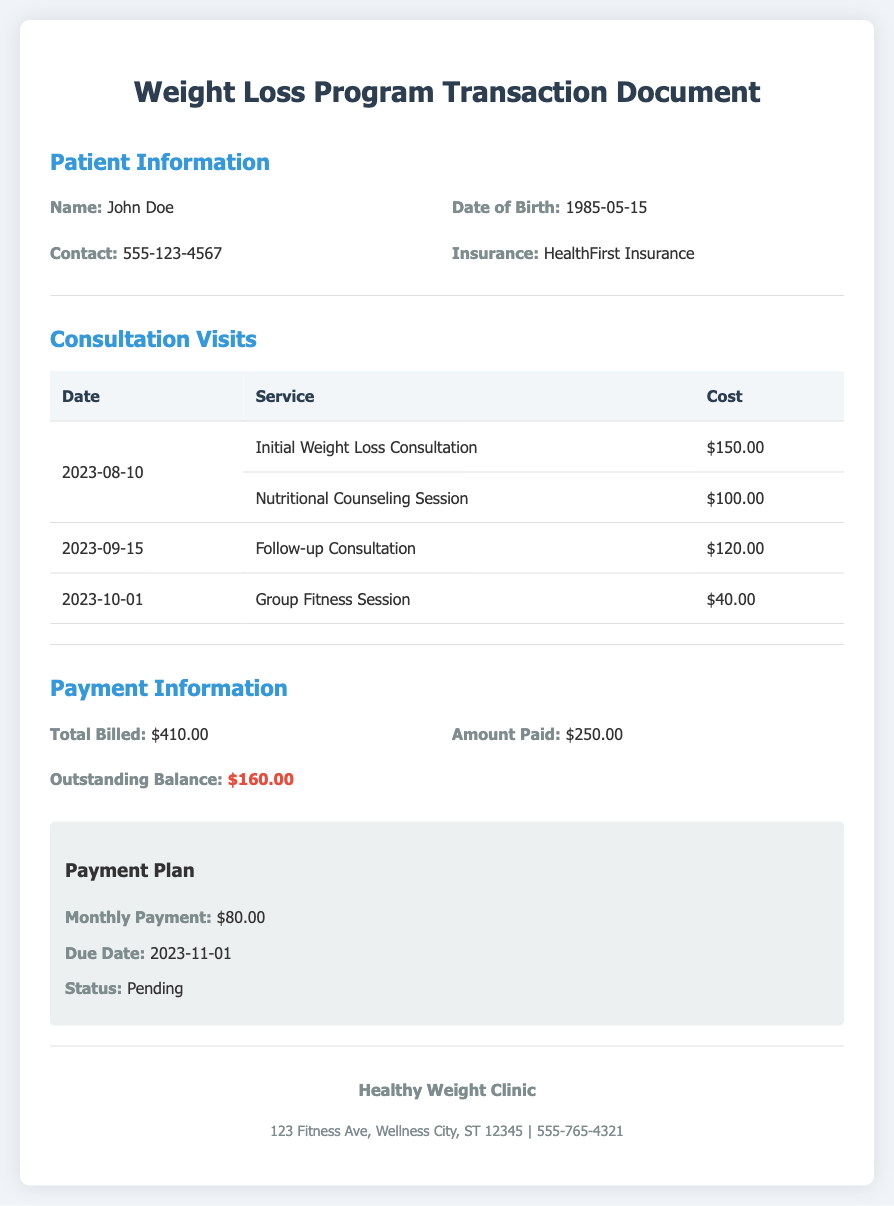What is the patient's name? The document specifies the patient's name in the patient information section.
Answer: John Doe What is the total billed amount? The total billed amount can be found in the payment information section of the document.
Answer: $410.00 What date is the outstanding balance due? The due date is highlighted in the payment plan within the payment information section.
Answer: 2023-11-01 How much was paid so far? The amount paid is listed directly in the payment information section.
Answer: $250.00 Which service was rendered on 2023-09-15? The specific service provided on this date is recorded under consultation visits.
Answer: Follow-up Consultation What is the outstanding balance? The outstanding balance is explicitly indicated in the payment information section as the difference between total billed and amount paid.
Answer: $160.00 What type of consultation was the first visit? This information is detailed in the consultation visits table as the first service rendered.
Answer: Initial Weight Loss Consultation What is the status of the payment plan? The status is provided within the payment plan section under payment information.
Answer: Pending What was the cost of the Group Fitness Session? The cost of this specific session is detailed in the consultation visits table.
Answer: $40.00 